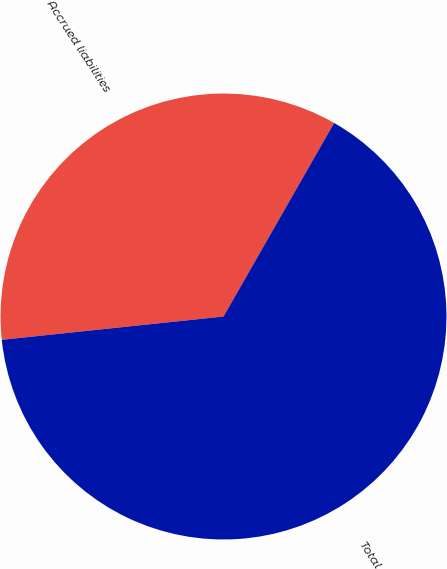Convert chart to OTSL. <chart><loc_0><loc_0><loc_500><loc_500><pie_chart><fcel>Accrued liabilities<fcel>Total<nl><fcel>34.93%<fcel>65.07%<nl></chart> 